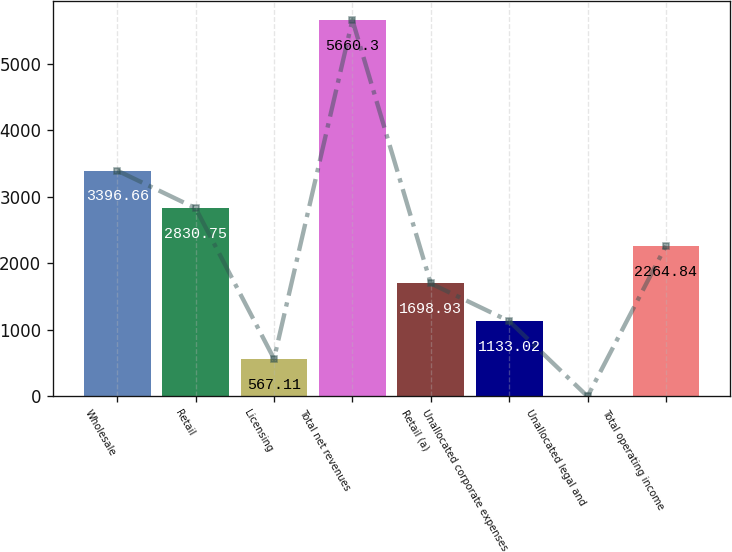Convert chart. <chart><loc_0><loc_0><loc_500><loc_500><bar_chart><fcel>Wholesale<fcel>Retail<fcel>Licensing<fcel>Total net revenues<fcel>Retail (a)<fcel>Unallocated corporate expenses<fcel>Unallocated legal and<fcel>Total operating income<nl><fcel>3396.66<fcel>2830.75<fcel>567.11<fcel>5660.3<fcel>1698.93<fcel>1133.02<fcel>1.2<fcel>2264.84<nl></chart> 